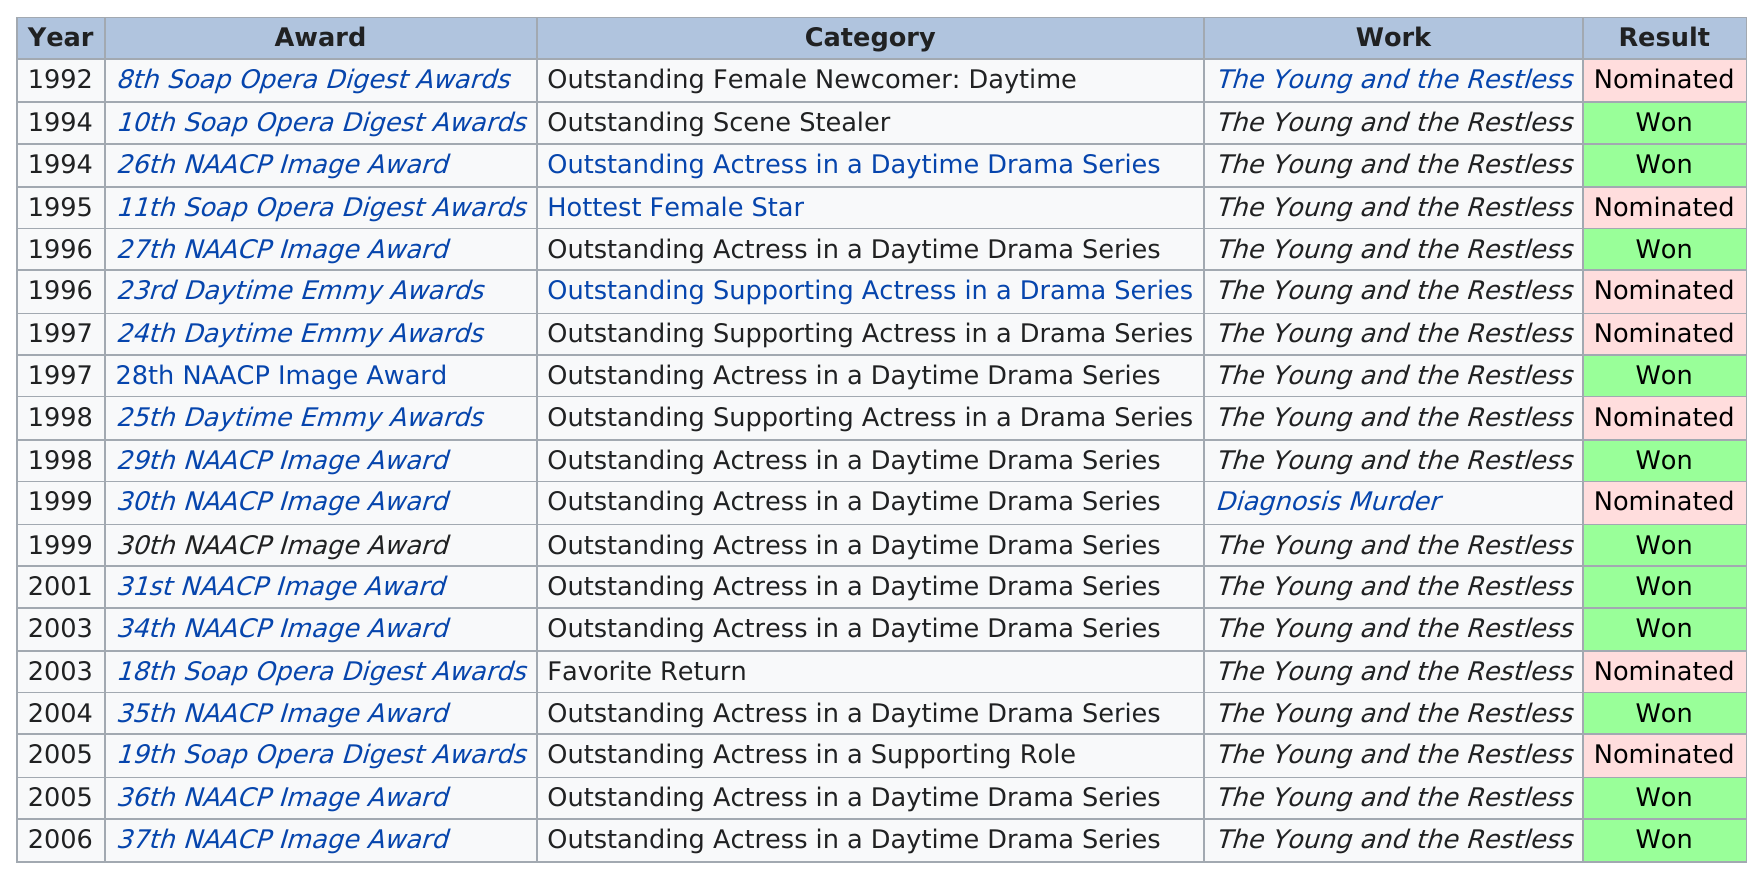Outline some significant characteristics in this image. The answer to the question "did she get the same award in 2005, as she did in 2006? Yes." is "Yes, she did get the same award in 2005 as she did in 2006. The award has been won 10 times by the person named Rowell. In 1992, she was nominated for the first time and won. Rowell has been nominated for a Daytime Emmy Award three times. The woman was nominated for awards multiple times, a total of 8 times, but she did not win any of them. 